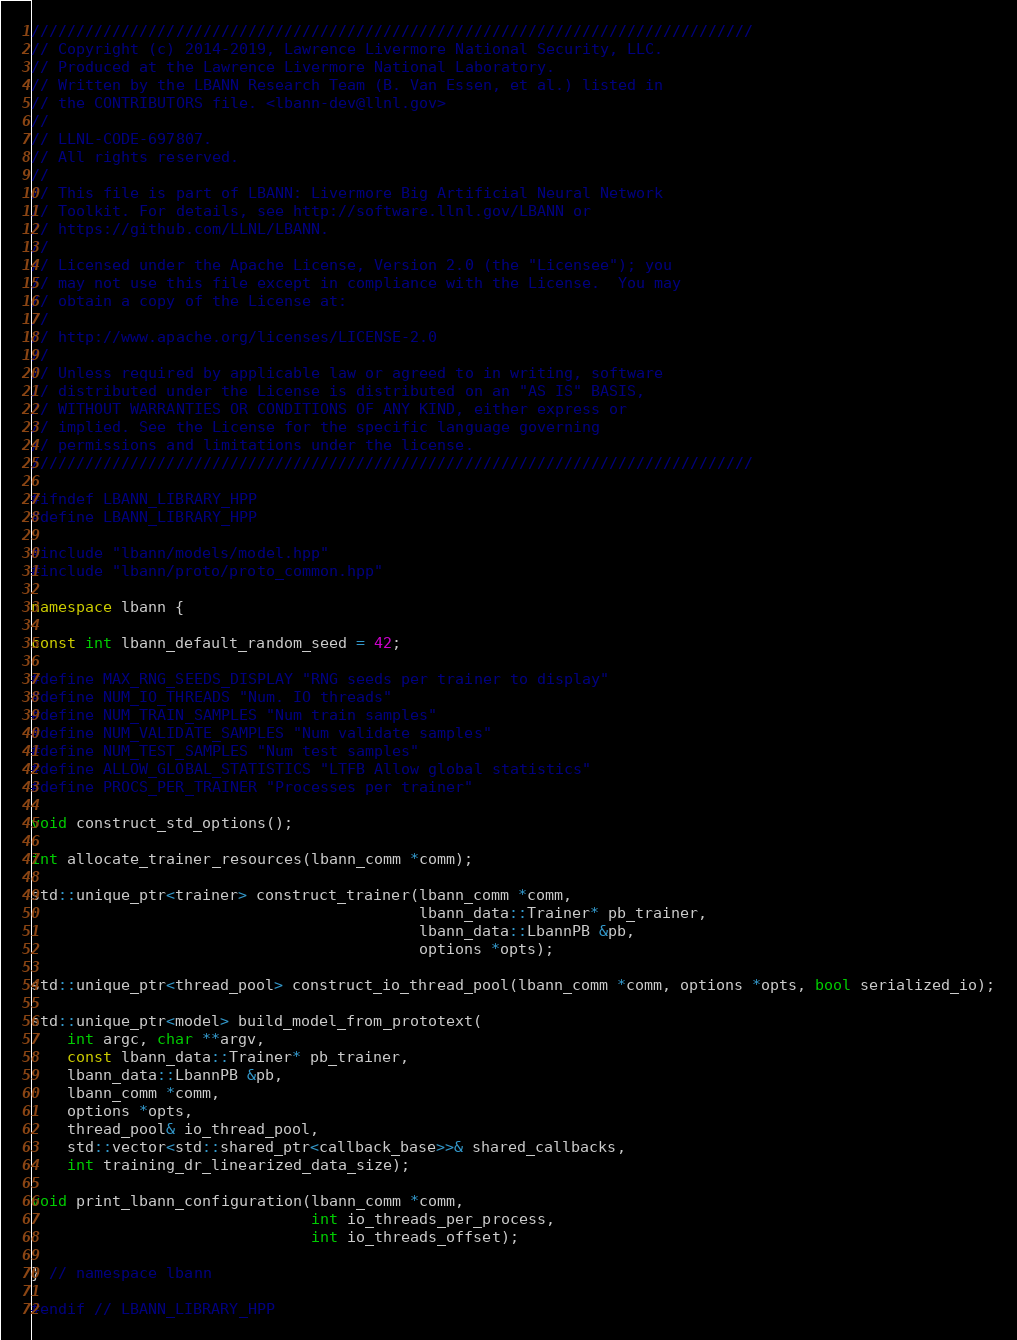<code> <loc_0><loc_0><loc_500><loc_500><_C++_>////////////////////////////////////////////////////////////////////////////////
// Copyright (c) 2014-2019, Lawrence Livermore National Security, LLC.
// Produced at the Lawrence Livermore National Laboratory.
// Written by the LBANN Research Team (B. Van Essen, et al.) listed in
// the CONTRIBUTORS file. <lbann-dev@llnl.gov>
//
// LLNL-CODE-697807.
// All rights reserved.
//
// This file is part of LBANN: Livermore Big Artificial Neural Network
// Toolkit. For details, see http://software.llnl.gov/LBANN or
// https://github.com/LLNL/LBANN.
//
// Licensed under the Apache License, Version 2.0 (the "Licensee"); you
// may not use this file except in compliance with the License.  You may
// obtain a copy of the License at:
//
// http://www.apache.org/licenses/LICENSE-2.0
//
// Unless required by applicable law or agreed to in writing, software
// distributed under the License is distributed on an "AS IS" BASIS,
// WITHOUT WARRANTIES OR CONDITIONS OF ANY KIND, either express or
// implied. See the License for the specific language governing
// permissions and limitations under the license.
////////////////////////////////////////////////////////////////////////////////

#ifndef LBANN_LIBRARY_HPP
#define LBANN_LIBRARY_HPP

#include "lbann/models/model.hpp"
#include "lbann/proto/proto_common.hpp"

namespace lbann {

const int lbann_default_random_seed = 42;

#define MAX_RNG_SEEDS_DISPLAY "RNG seeds per trainer to display"
#define NUM_IO_THREADS "Num. IO threads"
#define NUM_TRAIN_SAMPLES "Num train samples"
#define NUM_VALIDATE_SAMPLES "Num validate samples"
#define NUM_TEST_SAMPLES "Num test samples"
#define ALLOW_GLOBAL_STATISTICS "LTFB Allow global statistics"
#define PROCS_PER_TRAINER "Processes per trainer"

void construct_std_options();

int allocate_trainer_resources(lbann_comm *comm);

std::unique_ptr<trainer> construct_trainer(lbann_comm *comm,
                                           lbann_data::Trainer* pb_trainer,
                                           lbann_data::LbannPB &pb,
                                           options *opts);

std::unique_ptr<thread_pool> construct_io_thread_pool(lbann_comm *comm, options *opts, bool serialized_io);

std::unique_ptr<model> build_model_from_prototext(
    int argc, char **argv,
    const lbann_data::Trainer* pb_trainer,
    lbann_data::LbannPB &pb,
    lbann_comm *comm,
    options *opts,
    thread_pool& io_thread_pool,
    std::vector<std::shared_ptr<callback_base>>& shared_callbacks,
    int training_dr_linearized_data_size);

void print_lbann_configuration(lbann_comm *comm,
                               int io_threads_per_process,
                               int io_threads_offset);

} // namespace lbann

#endif // LBANN_LIBRARY_HPP
</code> 